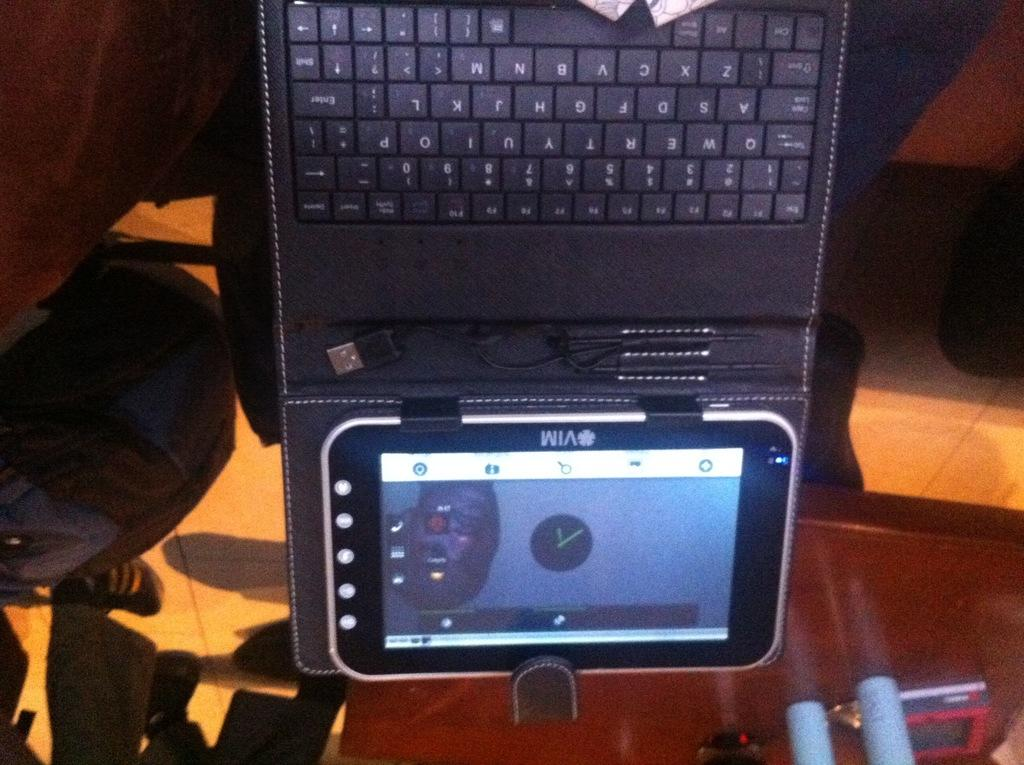<image>
Relay a brief, clear account of the picture shown. An electronic device is made by a company called VIM. 